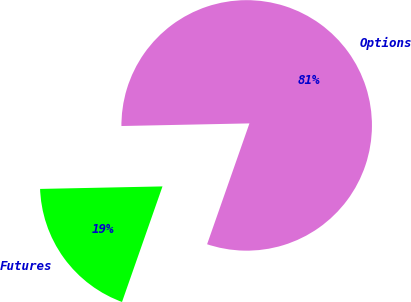<chart> <loc_0><loc_0><loc_500><loc_500><pie_chart><fcel>Options<fcel>Futures<nl><fcel>80.69%<fcel>19.31%<nl></chart> 